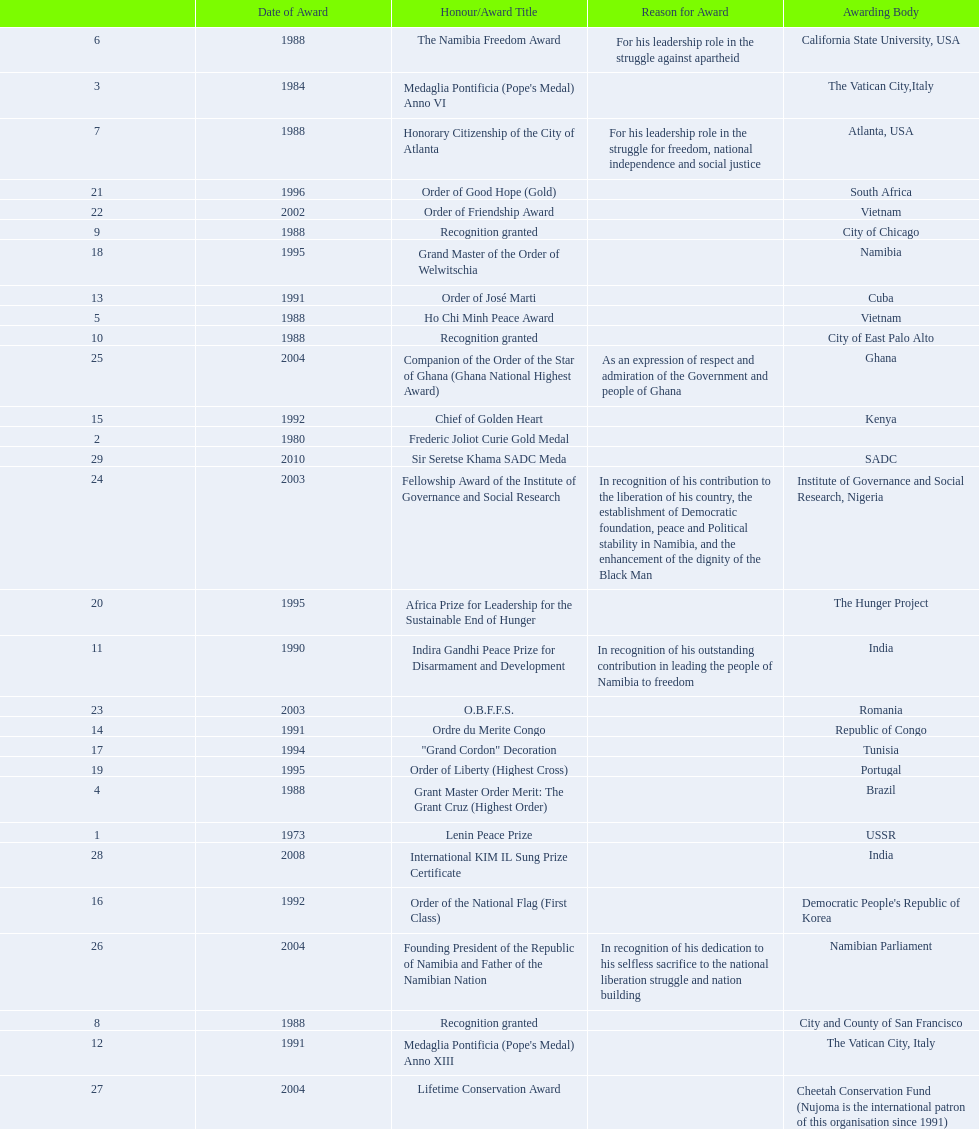Which awarding bodies have recognized sam nujoma? USSR, , The Vatican City,Italy, Brazil, Vietnam, California State University, USA, Atlanta, USA, City and County of San Francisco, City of Chicago, City of East Palo Alto, India, The Vatican City, Italy, Cuba, Republic of Congo, Kenya, Democratic People's Republic of Korea, Tunisia, Namibia, Portugal, The Hunger Project, South Africa, Vietnam, Romania, Institute of Governance and Social Research, Nigeria, Ghana, Namibian Parliament, Cheetah Conservation Fund (Nujoma is the international patron of this organisation since 1991), India, SADC. And what was the title of each award or honour? Lenin Peace Prize, Frederic Joliot Curie Gold Medal, Medaglia Pontificia (Pope's Medal) Anno VI, Grant Master Order Merit: The Grant Cruz (Highest Order), Ho Chi Minh Peace Award, The Namibia Freedom Award, Honorary Citizenship of the City of Atlanta, Recognition granted, Recognition granted, Recognition granted, Indira Gandhi Peace Prize for Disarmament and Development, Medaglia Pontificia (Pope's Medal) Anno XIII, Order of José Marti, Ordre du Merite Congo, Chief of Golden Heart, Order of the National Flag (First Class), "Grand Cordon" Decoration, Grand Master of the Order of Welwitschia, Order of Liberty (Highest Cross), Africa Prize for Leadership for the Sustainable End of Hunger, Order of Good Hope (Gold), Order of Friendship Award, O.B.F.F.S., Fellowship Award of the Institute of Governance and Social Research, Companion of the Order of the Star of Ghana (Ghana National Highest Award), Founding President of the Republic of Namibia and Father of the Namibian Nation, Lifetime Conservation Award, International KIM IL Sung Prize Certificate, Sir Seretse Khama SADC Meda. Of those, which nation awarded him the o.b.f.f.s.? Romania. 